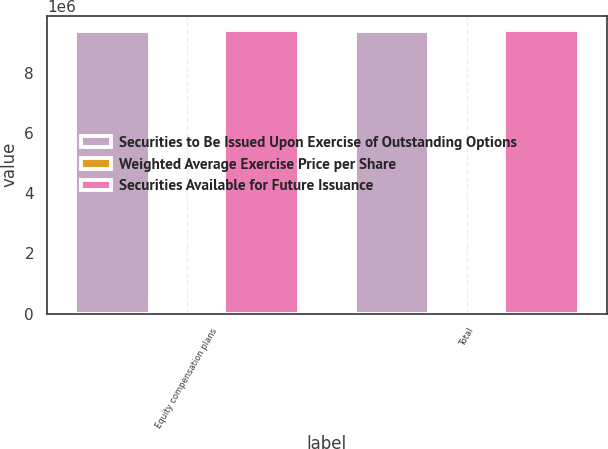Convert chart. <chart><loc_0><loc_0><loc_500><loc_500><stacked_bar_chart><ecel><fcel>Equity compensation plans<fcel>Total<nl><fcel>Securities to Be Issued Upon Exercise of Outstanding Options<fcel>9.42575e+06<fcel>9.42575e+06<nl><fcel>Weighted Average Exercise Price per Share<fcel>35.5<fcel>35.5<nl><fcel>Securities Available for Future Issuance<fcel>9.44162e+06<fcel>9.44162e+06<nl></chart> 